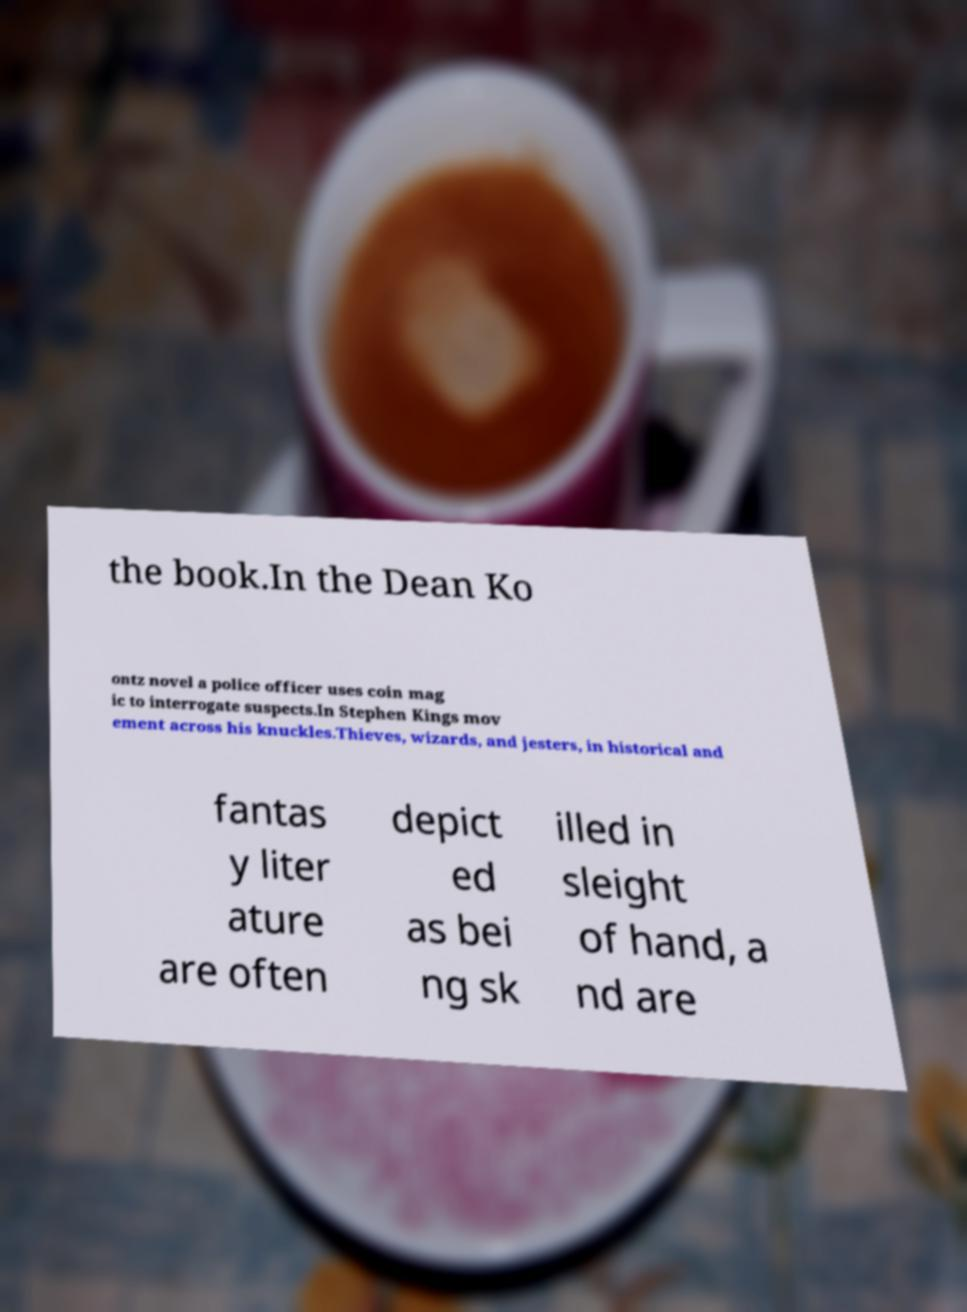There's text embedded in this image that I need extracted. Can you transcribe it verbatim? the book.In the Dean Ko ontz novel a police officer uses coin mag ic to interrogate suspects.In Stephen Kings mov ement across his knuckles.Thieves, wizards, and jesters, in historical and fantas y liter ature are often depict ed as bei ng sk illed in sleight of hand, a nd are 